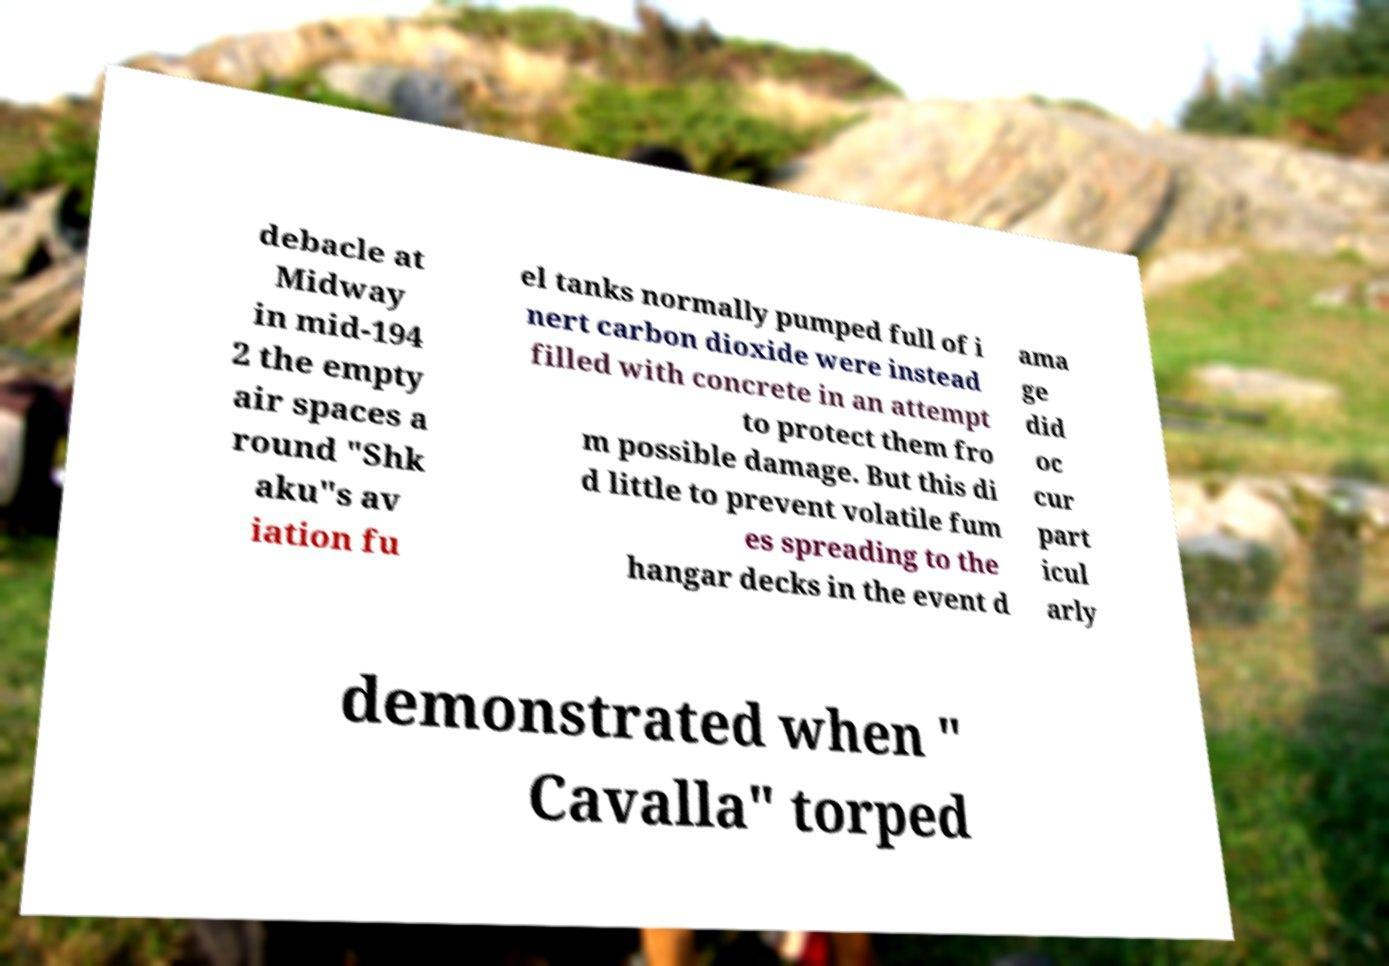Can you read and provide the text displayed in the image?This photo seems to have some interesting text. Can you extract and type it out for me? debacle at Midway in mid-194 2 the empty air spaces a round "Shk aku"s av iation fu el tanks normally pumped full of i nert carbon dioxide were instead filled with concrete in an attempt to protect them fro m possible damage. But this di d little to prevent volatile fum es spreading to the hangar decks in the event d ama ge did oc cur part icul arly demonstrated when " Cavalla" torped 